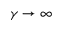Convert formula to latex. <formula><loc_0><loc_0><loc_500><loc_500>\gamma \to \infty</formula> 